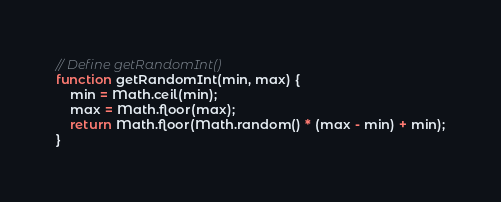<code> <loc_0><loc_0><loc_500><loc_500><_JavaScript_>// Define getRandomInt()
function getRandomInt(min, max) {
    min = Math.ceil(min);
    max = Math.floor(max);
    return Math.floor(Math.random() * (max - min) + min);
}</code> 